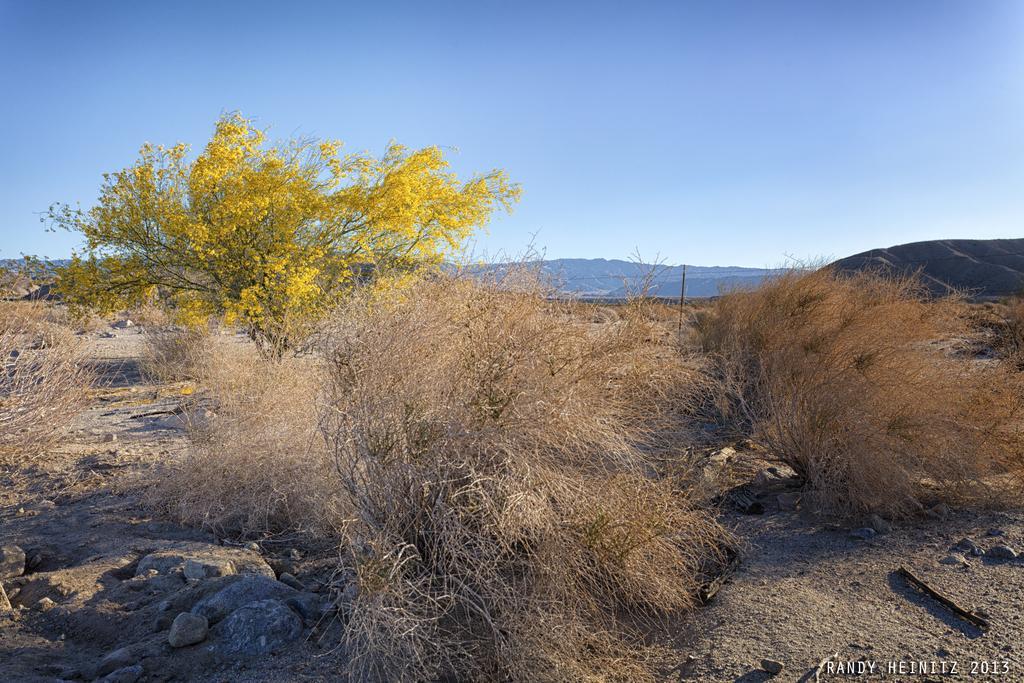In one or two sentences, can you explain what this image depicts? In the foreground of the image there are dry plants. At the bottom of the image there are stones. There is rock. In the background of the image there are mountains. There is a yellow color tree. 